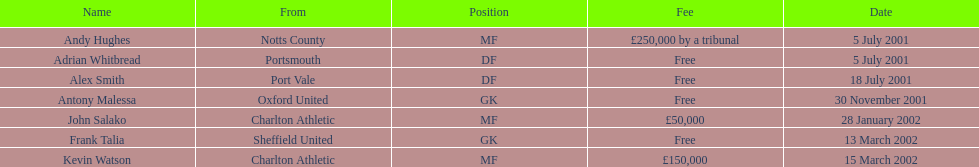What are the names of all the players? Andy Hughes, Adrian Whitbread, Alex Smith, Antony Malessa, John Salako, Frank Talia, Kevin Watson. What fee did andy hughes command? £250,000 by a tribunal. What fee did john salako command? £50,000. Which player had the highest fee, andy hughes or john salako? Andy Hughes. 